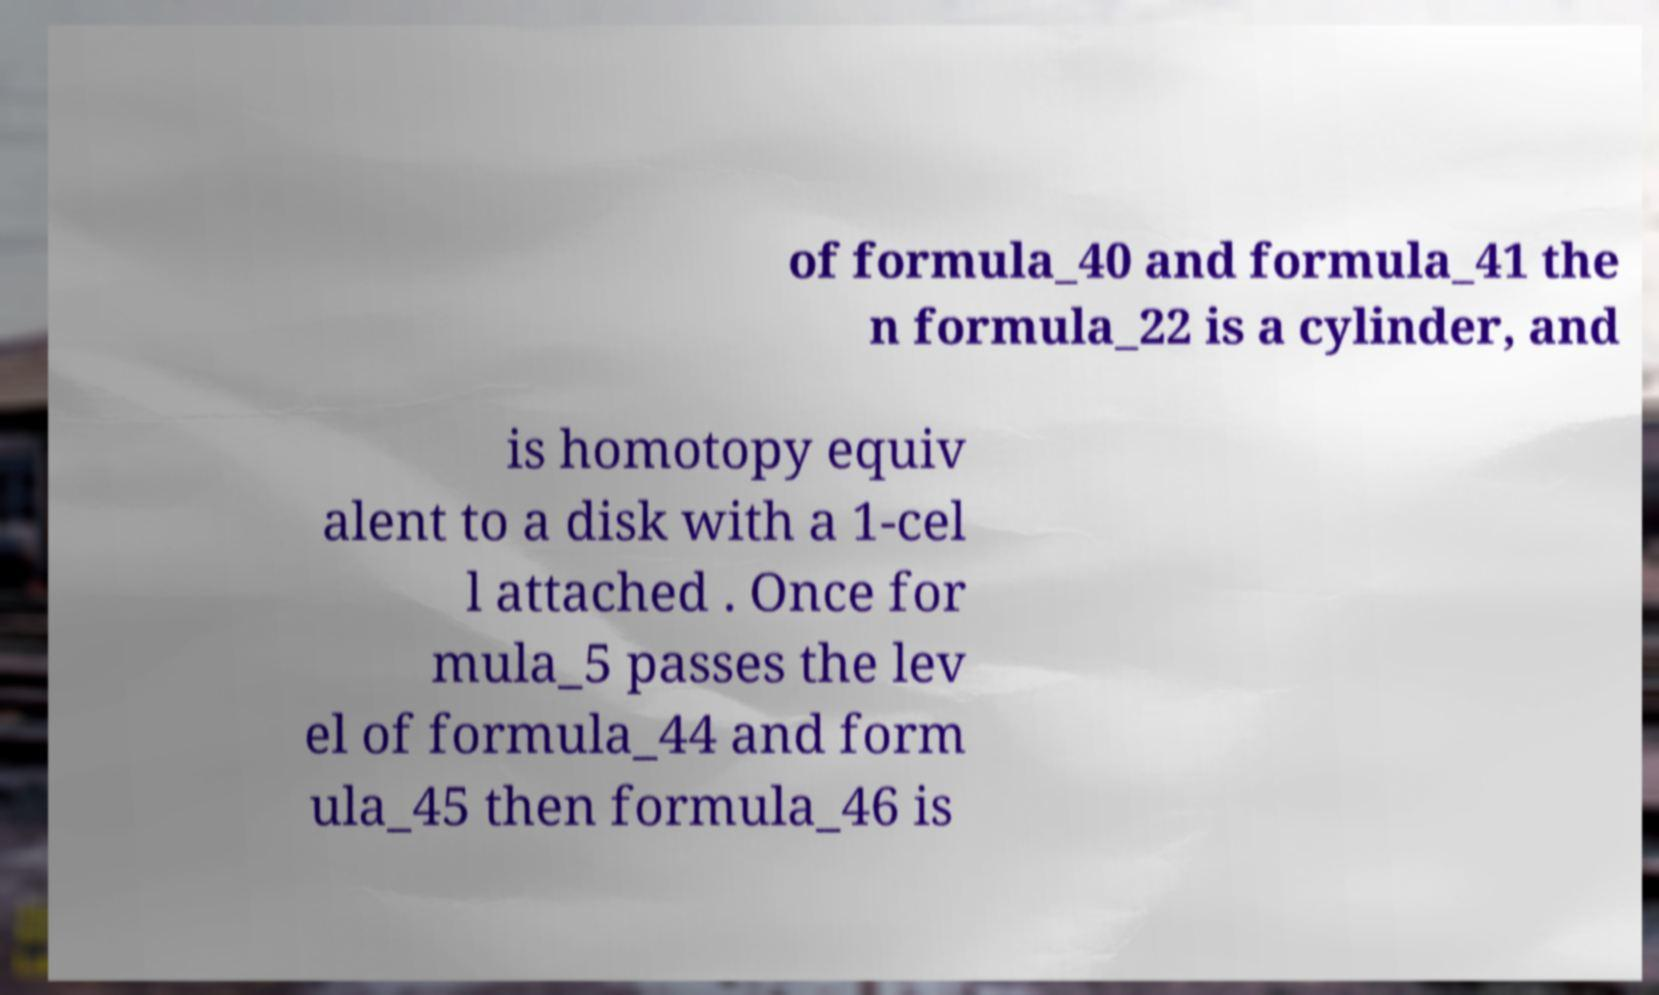Can you read and provide the text displayed in the image?This photo seems to have some interesting text. Can you extract and type it out for me? of formula_40 and formula_41 the n formula_22 is a cylinder, and is homotopy equiv alent to a disk with a 1-cel l attached . Once for mula_5 passes the lev el of formula_44 and form ula_45 then formula_46 is 